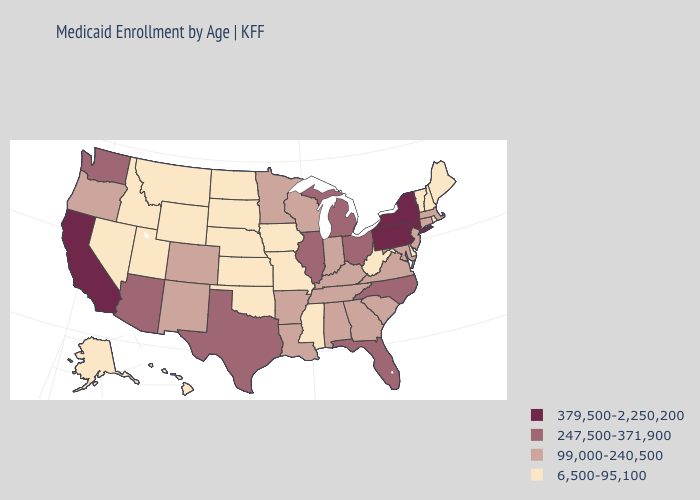Does the first symbol in the legend represent the smallest category?
Quick response, please. No. Which states have the highest value in the USA?
Short answer required. California, New York, Pennsylvania. Does Oklahoma have a lower value than Oregon?
Answer briefly. Yes. Name the states that have a value in the range 99,000-240,500?
Give a very brief answer. Alabama, Arkansas, Colorado, Connecticut, Georgia, Indiana, Kentucky, Louisiana, Maryland, Massachusetts, Minnesota, New Jersey, New Mexico, Oregon, South Carolina, Tennessee, Virginia, Wisconsin. Does Alabama have the lowest value in the South?
Keep it brief. No. Among the states that border Tennessee , which have the lowest value?
Concise answer only. Mississippi, Missouri. What is the value of Arkansas?
Short answer required. 99,000-240,500. What is the lowest value in states that border Arkansas?
Keep it brief. 6,500-95,100. Among the states that border South Carolina , which have the lowest value?
Keep it brief. Georgia. Name the states that have a value in the range 99,000-240,500?
Short answer required. Alabama, Arkansas, Colorado, Connecticut, Georgia, Indiana, Kentucky, Louisiana, Maryland, Massachusetts, Minnesota, New Jersey, New Mexico, Oregon, South Carolina, Tennessee, Virginia, Wisconsin. Does Kansas have the highest value in the USA?
Give a very brief answer. No. Name the states that have a value in the range 6,500-95,100?
Write a very short answer. Alaska, Delaware, Hawaii, Idaho, Iowa, Kansas, Maine, Mississippi, Missouri, Montana, Nebraska, Nevada, New Hampshire, North Dakota, Oklahoma, Rhode Island, South Dakota, Utah, Vermont, West Virginia, Wyoming. Name the states that have a value in the range 379,500-2,250,200?
Short answer required. California, New York, Pennsylvania. 